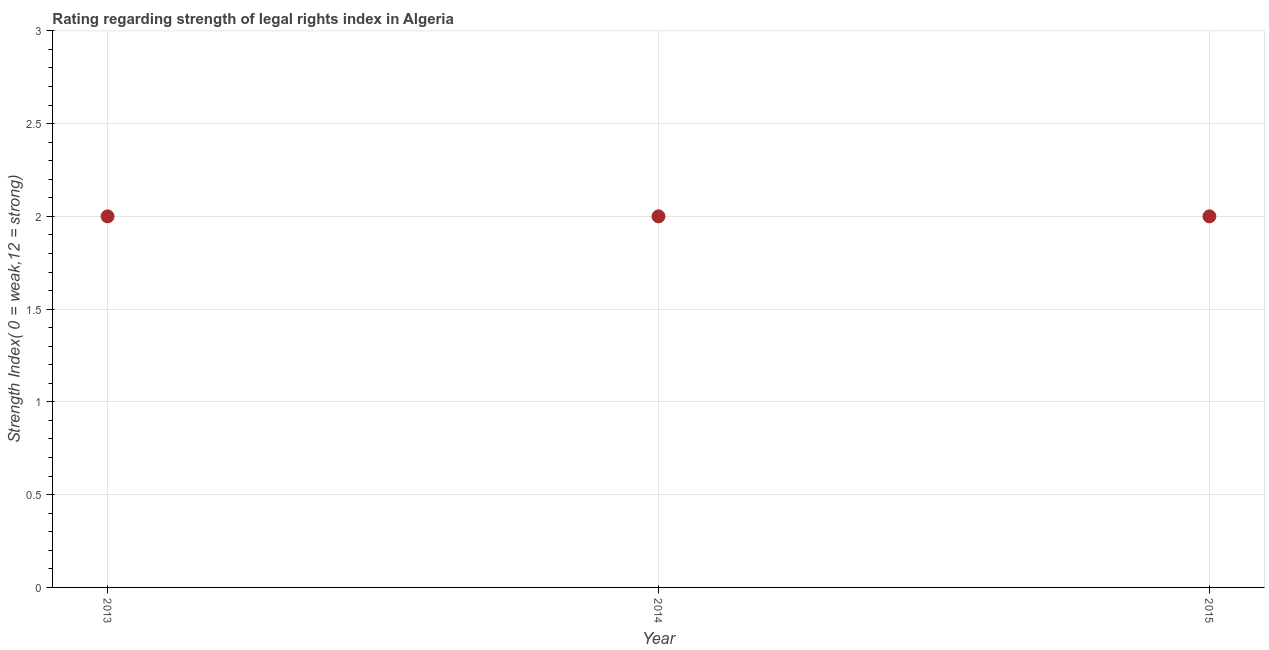What is the strength of legal rights index in 2014?
Your answer should be very brief. 2. Across all years, what is the maximum strength of legal rights index?
Provide a succinct answer. 2. Across all years, what is the minimum strength of legal rights index?
Give a very brief answer. 2. In which year was the strength of legal rights index minimum?
Keep it short and to the point. 2013. In how many years, is the strength of legal rights index greater than 0.8 ?
Offer a terse response. 3. Is the strength of legal rights index in 2014 less than that in 2015?
Provide a short and direct response. No. Is the difference between the strength of legal rights index in 2014 and 2015 greater than the difference between any two years?
Your response must be concise. Yes. What is the difference between the highest and the second highest strength of legal rights index?
Your answer should be compact. 0. Is the sum of the strength of legal rights index in 2013 and 2015 greater than the maximum strength of legal rights index across all years?
Give a very brief answer. Yes. What is the difference between the highest and the lowest strength of legal rights index?
Offer a terse response. 0. In how many years, is the strength of legal rights index greater than the average strength of legal rights index taken over all years?
Your answer should be very brief. 0. Does the strength of legal rights index monotonically increase over the years?
Make the answer very short. No. What is the title of the graph?
Provide a succinct answer. Rating regarding strength of legal rights index in Algeria. What is the label or title of the X-axis?
Your answer should be very brief. Year. What is the label or title of the Y-axis?
Offer a terse response. Strength Index( 0 = weak,12 = strong). What is the Strength Index( 0 = weak,12 = strong) in 2014?
Offer a terse response. 2. What is the difference between the Strength Index( 0 = weak,12 = strong) in 2013 and 2014?
Ensure brevity in your answer.  0. What is the difference between the Strength Index( 0 = weak,12 = strong) in 2014 and 2015?
Ensure brevity in your answer.  0. 